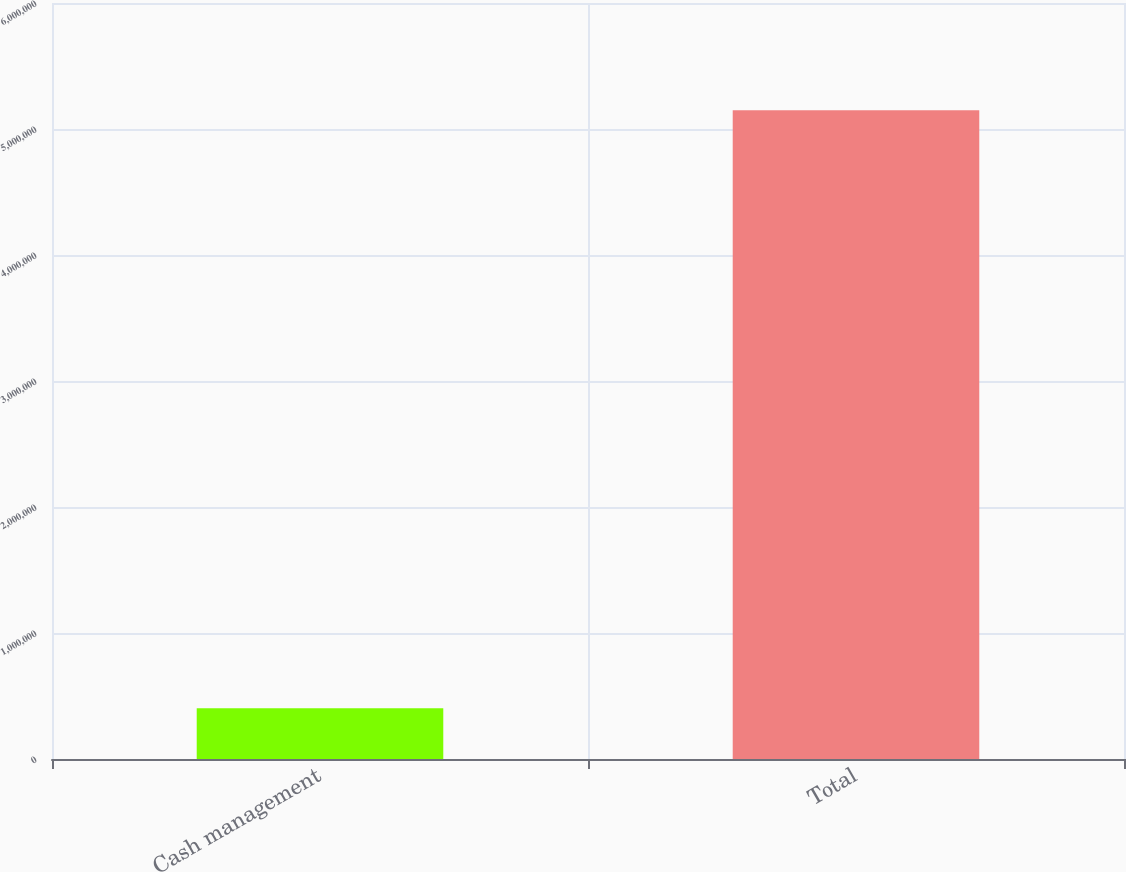Convert chart to OTSL. <chart><loc_0><loc_0><loc_500><loc_500><bar_chart><fcel>Cash management<fcel>Total<nl><fcel>403584<fcel>5.14785e+06<nl></chart> 